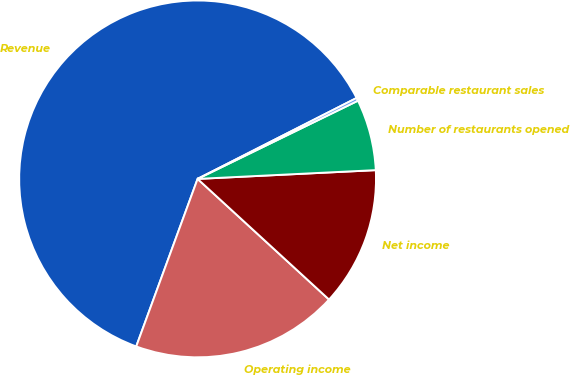Convert chart to OTSL. <chart><loc_0><loc_0><loc_500><loc_500><pie_chart><fcel>Revenue<fcel>Operating income<fcel>Net income<fcel>Number of restaurants opened<fcel>Comparable restaurant sales<nl><fcel>61.92%<fcel>18.77%<fcel>12.6%<fcel>6.44%<fcel>0.27%<nl></chart> 